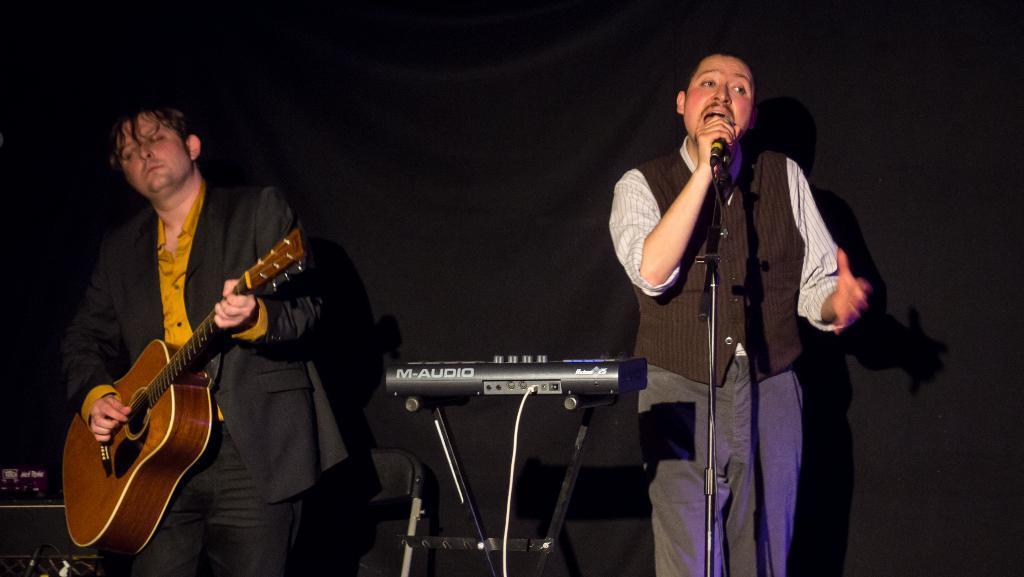Please provide a concise description of this image. In this picture we can see two persons on left side person holding guitar and playing it and on right side person singing on mic and in between them we have some musical instrument and the background we can see chair and it is dark. 